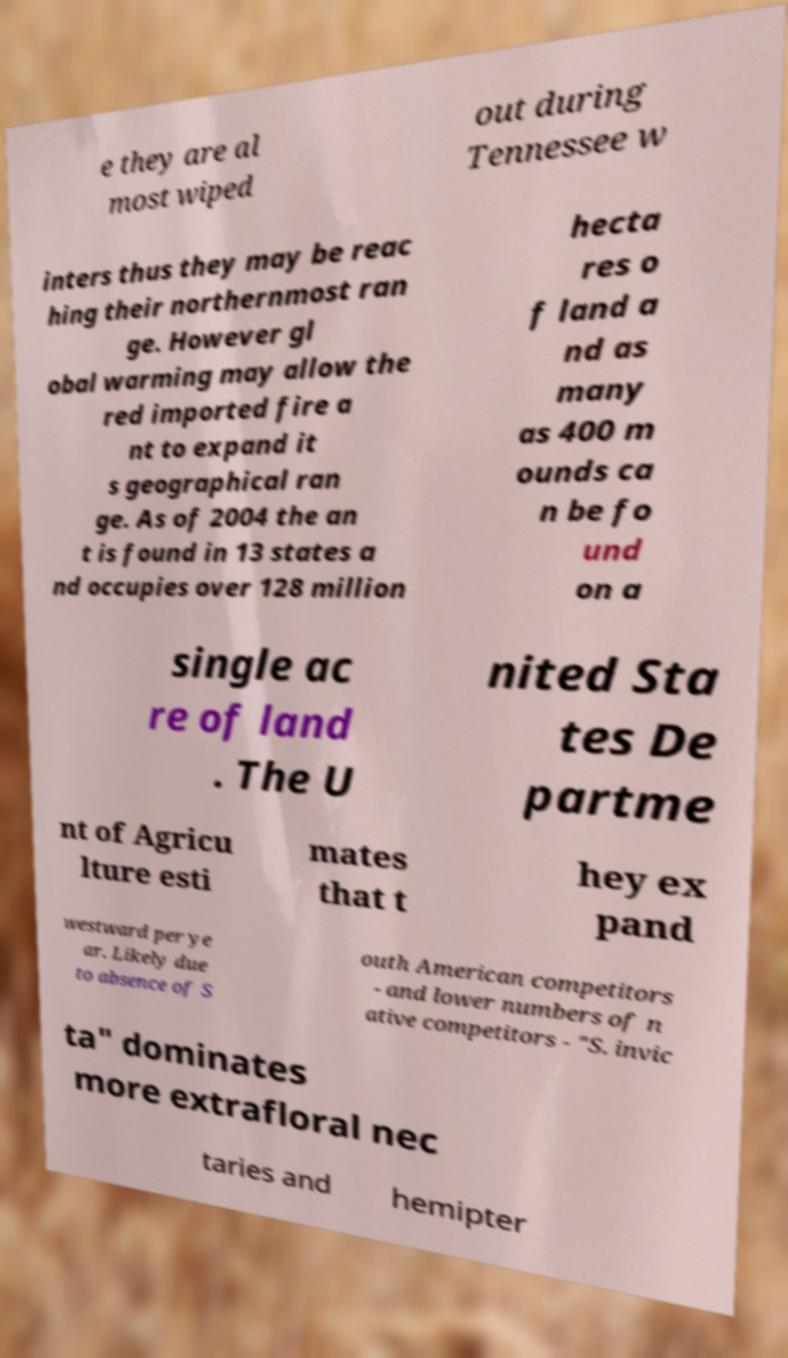Could you extract and type out the text from this image? e they are al most wiped out during Tennessee w inters thus they may be reac hing their northernmost ran ge. However gl obal warming may allow the red imported fire a nt to expand it s geographical ran ge. As of 2004 the an t is found in 13 states a nd occupies over 128 million hecta res o f land a nd as many as 400 m ounds ca n be fo und on a single ac re of land . The U nited Sta tes De partme nt of Agricu lture esti mates that t hey ex pand westward per ye ar. Likely due to absence of S outh American competitors - and lower numbers of n ative competitors - "S. invic ta" dominates more extrafloral nec taries and hemipter 